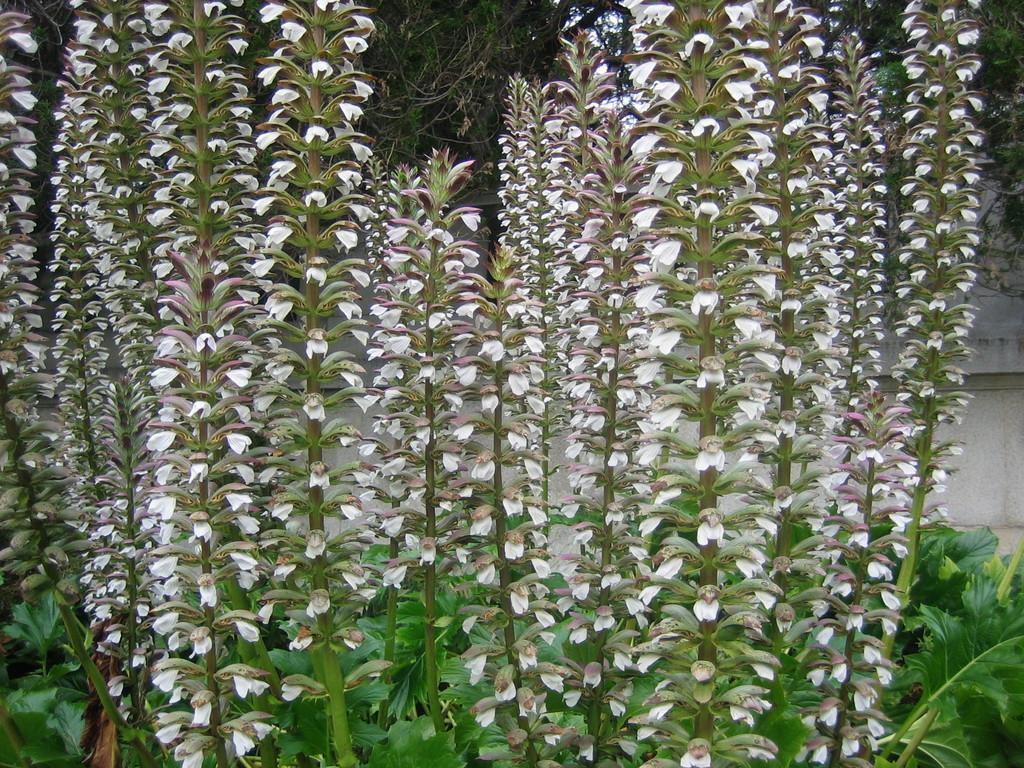What types of living organisms can be seen in the image? There are many plants in the image. What specific features can be observed on the plants? There are flowers on the plants in the image. What type of earthquake can be seen in the image? There is no earthquake present in the image; it features plants with flowers. Can you describe the driving conditions in the image? There is no driving or road depicted in the image, as it focuses on plants with flowers. 